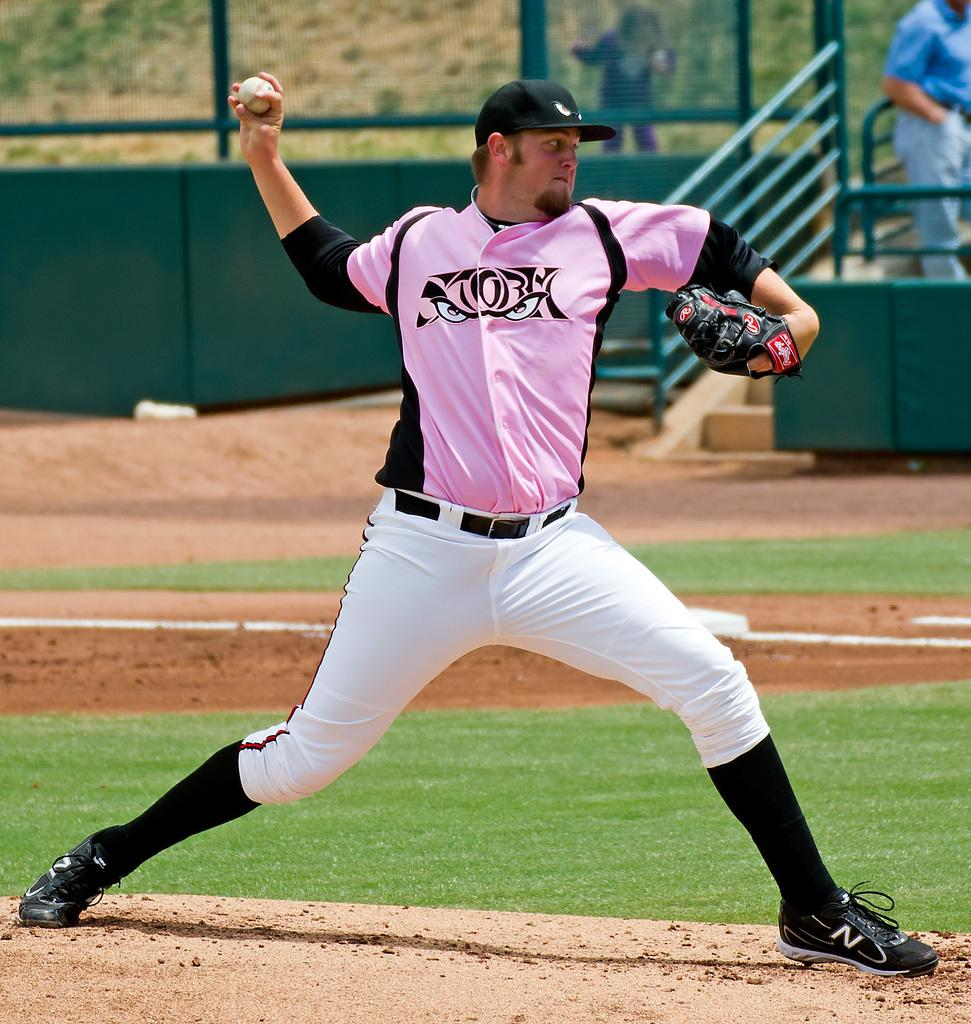<image>
Describe the image concisely. A man in a pink shirt has a small red R on his baseball glove near the finger tips. 